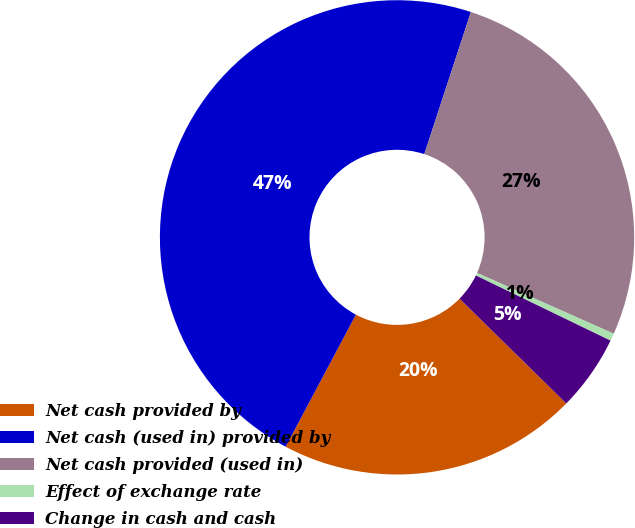Convert chart to OTSL. <chart><loc_0><loc_0><loc_500><loc_500><pie_chart><fcel>Net cash provided by<fcel>Net cash (used in) provided by<fcel>Net cash provided (used in)<fcel>Effect of exchange rate<fcel>Change in cash and cash<nl><fcel>20.43%<fcel>47.26%<fcel>26.62%<fcel>0.51%<fcel>5.18%<nl></chart> 